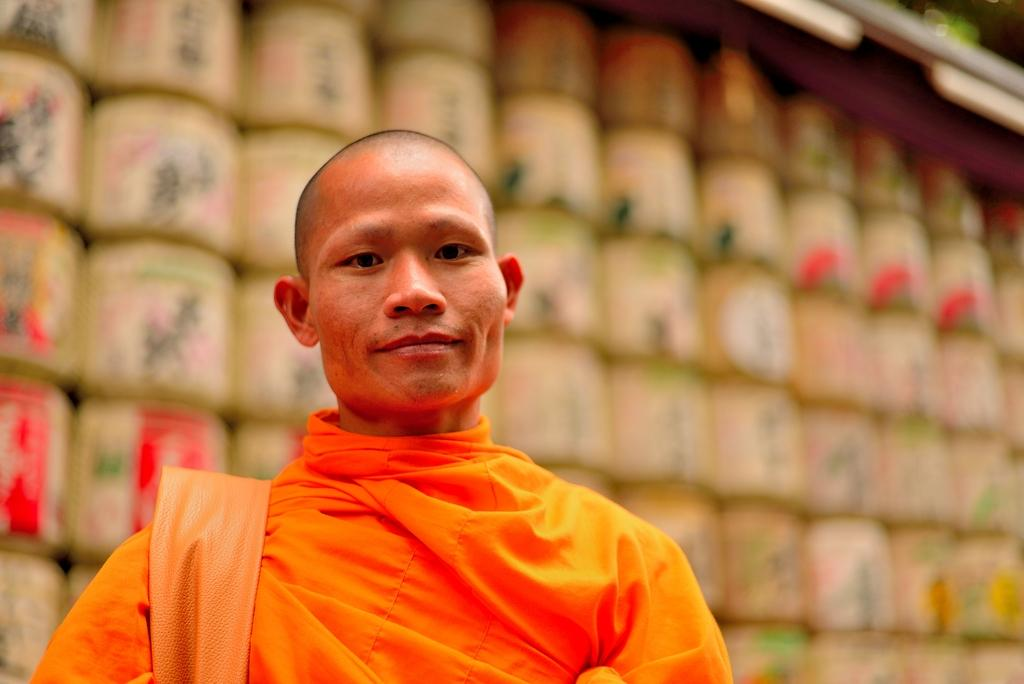What is present in the image? There is a person in the image. Can you describe the person's clothing? The person is wearing orange color clothes. What can be observed about the background of the image? The background of the image is blurred. What type of goose can be seen in the image? There is no goose present in the image. What is the person using to carry the pail and box in the image? There is no pail or box present in the image. 